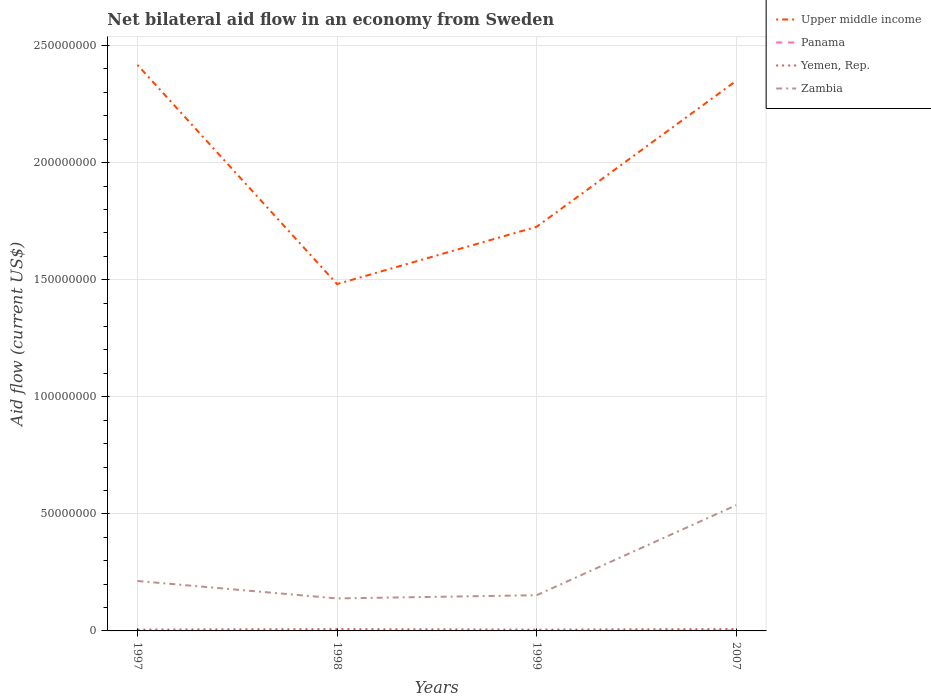Is the number of lines equal to the number of legend labels?
Ensure brevity in your answer.  Yes. Across all years, what is the maximum net bilateral aid flow in Upper middle income?
Offer a very short reply. 1.48e+08. In which year was the net bilateral aid flow in Yemen, Rep. maximum?
Your response must be concise. 1999. What is the difference between the highest and the lowest net bilateral aid flow in Yemen, Rep.?
Give a very brief answer. 2. Is the net bilateral aid flow in Zambia strictly greater than the net bilateral aid flow in Upper middle income over the years?
Your answer should be very brief. Yes. How many lines are there?
Offer a very short reply. 4. What is the difference between two consecutive major ticks on the Y-axis?
Keep it short and to the point. 5.00e+07. Are the values on the major ticks of Y-axis written in scientific E-notation?
Ensure brevity in your answer.  No. Does the graph contain any zero values?
Offer a very short reply. No. Does the graph contain grids?
Ensure brevity in your answer.  Yes. Where does the legend appear in the graph?
Your answer should be compact. Top right. What is the title of the graph?
Offer a very short reply. Net bilateral aid flow in an economy from Sweden. Does "Georgia" appear as one of the legend labels in the graph?
Offer a very short reply. No. What is the label or title of the Y-axis?
Provide a short and direct response. Aid flow (current US$). What is the Aid flow (current US$) in Upper middle income in 1997?
Provide a succinct answer. 2.42e+08. What is the Aid flow (current US$) of Yemen, Rep. in 1997?
Offer a terse response. 5.60e+05. What is the Aid flow (current US$) of Zambia in 1997?
Your answer should be very brief. 2.13e+07. What is the Aid flow (current US$) in Upper middle income in 1998?
Offer a terse response. 1.48e+08. What is the Aid flow (current US$) of Panama in 1998?
Your answer should be very brief. 2.00e+04. What is the Aid flow (current US$) in Yemen, Rep. in 1998?
Give a very brief answer. 7.70e+05. What is the Aid flow (current US$) in Zambia in 1998?
Ensure brevity in your answer.  1.39e+07. What is the Aid flow (current US$) of Upper middle income in 1999?
Provide a short and direct response. 1.73e+08. What is the Aid flow (current US$) in Panama in 1999?
Ensure brevity in your answer.  10000. What is the Aid flow (current US$) in Zambia in 1999?
Offer a terse response. 1.52e+07. What is the Aid flow (current US$) of Upper middle income in 2007?
Your answer should be very brief. 2.35e+08. What is the Aid flow (current US$) of Panama in 2007?
Provide a succinct answer. 1.40e+05. What is the Aid flow (current US$) in Yemen, Rep. in 2007?
Your answer should be compact. 8.00e+05. What is the Aid flow (current US$) in Zambia in 2007?
Offer a terse response. 5.37e+07. Across all years, what is the maximum Aid flow (current US$) in Upper middle income?
Your answer should be compact. 2.42e+08. Across all years, what is the maximum Aid flow (current US$) of Panama?
Ensure brevity in your answer.  1.40e+05. Across all years, what is the maximum Aid flow (current US$) of Yemen, Rep.?
Your answer should be compact. 8.00e+05. Across all years, what is the maximum Aid flow (current US$) of Zambia?
Your response must be concise. 5.37e+07. Across all years, what is the minimum Aid flow (current US$) in Upper middle income?
Keep it short and to the point. 1.48e+08. Across all years, what is the minimum Aid flow (current US$) in Yemen, Rep.?
Ensure brevity in your answer.  5.50e+05. Across all years, what is the minimum Aid flow (current US$) of Zambia?
Ensure brevity in your answer.  1.39e+07. What is the total Aid flow (current US$) in Upper middle income in the graph?
Ensure brevity in your answer.  7.97e+08. What is the total Aid flow (current US$) of Panama in the graph?
Give a very brief answer. 1.90e+05. What is the total Aid flow (current US$) of Yemen, Rep. in the graph?
Ensure brevity in your answer.  2.68e+06. What is the total Aid flow (current US$) in Zambia in the graph?
Offer a very short reply. 1.04e+08. What is the difference between the Aid flow (current US$) of Upper middle income in 1997 and that in 1998?
Give a very brief answer. 9.36e+07. What is the difference between the Aid flow (current US$) of Zambia in 1997 and that in 1998?
Provide a short and direct response. 7.44e+06. What is the difference between the Aid flow (current US$) of Upper middle income in 1997 and that in 1999?
Make the answer very short. 6.91e+07. What is the difference between the Aid flow (current US$) of Zambia in 1997 and that in 1999?
Keep it short and to the point. 6.07e+06. What is the difference between the Aid flow (current US$) in Upper middle income in 1997 and that in 2007?
Ensure brevity in your answer.  6.81e+06. What is the difference between the Aid flow (current US$) of Yemen, Rep. in 1997 and that in 2007?
Provide a succinct answer. -2.40e+05. What is the difference between the Aid flow (current US$) in Zambia in 1997 and that in 2007?
Offer a terse response. -3.24e+07. What is the difference between the Aid flow (current US$) in Upper middle income in 1998 and that in 1999?
Offer a terse response. -2.45e+07. What is the difference between the Aid flow (current US$) of Zambia in 1998 and that in 1999?
Give a very brief answer. -1.37e+06. What is the difference between the Aid flow (current US$) in Upper middle income in 1998 and that in 2007?
Your answer should be compact. -8.68e+07. What is the difference between the Aid flow (current US$) in Panama in 1998 and that in 2007?
Provide a succinct answer. -1.20e+05. What is the difference between the Aid flow (current US$) in Yemen, Rep. in 1998 and that in 2007?
Your answer should be very brief. -3.00e+04. What is the difference between the Aid flow (current US$) in Zambia in 1998 and that in 2007?
Offer a terse response. -3.98e+07. What is the difference between the Aid flow (current US$) of Upper middle income in 1999 and that in 2007?
Ensure brevity in your answer.  -6.23e+07. What is the difference between the Aid flow (current US$) of Yemen, Rep. in 1999 and that in 2007?
Ensure brevity in your answer.  -2.50e+05. What is the difference between the Aid flow (current US$) in Zambia in 1999 and that in 2007?
Your answer should be compact. -3.84e+07. What is the difference between the Aid flow (current US$) in Upper middle income in 1997 and the Aid flow (current US$) in Panama in 1998?
Ensure brevity in your answer.  2.42e+08. What is the difference between the Aid flow (current US$) of Upper middle income in 1997 and the Aid flow (current US$) of Yemen, Rep. in 1998?
Your answer should be compact. 2.41e+08. What is the difference between the Aid flow (current US$) of Upper middle income in 1997 and the Aid flow (current US$) of Zambia in 1998?
Keep it short and to the point. 2.28e+08. What is the difference between the Aid flow (current US$) of Panama in 1997 and the Aid flow (current US$) of Yemen, Rep. in 1998?
Provide a succinct answer. -7.50e+05. What is the difference between the Aid flow (current US$) in Panama in 1997 and the Aid flow (current US$) in Zambia in 1998?
Offer a terse response. -1.39e+07. What is the difference between the Aid flow (current US$) of Yemen, Rep. in 1997 and the Aid flow (current US$) of Zambia in 1998?
Your response must be concise. -1.33e+07. What is the difference between the Aid flow (current US$) in Upper middle income in 1997 and the Aid flow (current US$) in Panama in 1999?
Give a very brief answer. 2.42e+08. What is the difference between the Aid flow (current US$) in Upper middle income in 1997 and the Aid flow (current US$) in Yemen, Rep. in 1999?
Your answer should be very brief. 2.41e+08. What is the difference between the Aid flow (current US$) of Upper middle income in 1997 and the Aid flow (current US$) of Zambia in 1999?
Your answer should be very brief. 2.26e+08. What is the difference between the Aid flow (current US$) in Panama in 1997 and the Aid flow (current US$) in Yemen, Rep. in 1999?
Keep it short and to the point. -5.30e+05. What is the difference between the Aid flow (current US$) in Panama in 1997 and the Aid flow (current US$) in Zambia in 1999?
Provide a succinct answer. -1.52e+07. What is the difference between the Aid flow (current US$) in Yemen, Rep. in 1997 and the Aid flow (current US$) in Zambia in 1999?
Offer a terse response. -1.47e+07. What is the difference between the Aid flow (current US$) of Upper middle income in 1997 and the Aid flow (current US$) of Panama in 2007?
Provide a succinct answer. 2.42e+08. What is the difference between the Aid flow (current US$) of Upper middle income in 1997 and the Aid flow (current US$) of Yemen, Rep. in 2007?
Ensure brevity in your answer.  2.41e+08. What is the difference between the Aid flow (current US$) in Upper middle income in 1997 and the Aid flow (current US$) in Zambia in 2007?
Ensure brevity in your answer.  1.88e+08. What is the difference between the Aid flow (current US$) in Panama in 1997 and the Aid flow (current US$) in Yemen, Rep. in 2007?
Your answer should be very brief. -7.80e+05. What is the difference between the Aid flow (current US$) of Panama in 1997 and the Aid flow (current US$) of Zambia in 2007?
Ensure brevity in your answer.  -5.37e+07. What is the difference between the Aid flow (current US$) of Yemen, Rep. in 1997 and the Aid flow (current US$) of Zambia in 2007?
Give a very brief answer. -5.31e+07. What is the difference between the Aid flow (current US$) in Upper middle income in 1998 and the Aid flow (current US$) in Panama in 1999?
Give a very brief answer. 1.48e+08. What is the difference between the Aid flow (current US$) of Upper middle income in 1998 and the Aid flow (current US$) of Yemen, Rep. in 1999?
Ensure brevity in your answer.  1.48e+08. What is the difference between the Aid flow (current US$) in Upper middle income in 1998 and the Aid flow (current US$) in Zambia in 1999?
Make the answer very short. 1.33e+08. What is the difference between the Aid flow (current US$) in Panama in 1998 and the Aid flow (current US$) in Yemen, Rep. in 1999?
Provide a short and direct response. -5.30e+05. What is the difference between the Aid flow (current US$) in Panama in 1998 and the Aid flow (current US$) in Zambia in 1999?
Keep it short and to the point. -1.52e+07. What is the difference between the Aid flow (current US$) of Yemen, Rep. in 1998 and the Aid flow (current US$) of Zambia in 1999?
Your answer should be very brief. -1.45e+07. What is the difference between the Aid flow (current US$) in Upper middle income in 1998 and the Aid flow (current US$) in Panama in 2007?
Your answer should be compact. 1.48e+08. What is the difference between the Aid flow (current US$) of Upper middle income in 1998 and the Aid flow (current US$) of Yemen, Rep. in 2007?
Ensure brevity in your answer.  1.47e+08. What is the difference between the Aid flow (current US$) of Upper middle income in 1998 and the Aid flow (current US$) of Zambia in 2007?
Provide a succinct answer. 9.44e+07. What is the difference between the Aid flow (current US$) of Panama in 1998 and the Aid flow (current US$) of Yemen, Rep. in 2007?
Provide a succinct answer. -7.80e+05. What is the difference between the Aid flow (current US$) of Panama in 1998 and the Aid flow (current US$) of Zambia in 2007?
Provide a short and direct response. -5.37e+07. What is the difference between the Aid flow (current US$) in Yemen, Rep. in 1998 and the Aid flow (current US$) in Zambia in 2007?
Your answer should be compact. -5.29e+07. What is the difference between the Aid flow (current US$) in Upper middle income in 1999 and the Aid flow (current US$) in Panama in 2007?
Ensure brevity in your answer.  1.72e+08. What is the difference between the Aid flow (current US$) in Upper middle income in 1999 and the Aid flow (current US$) in Yemen, Rep. in 2007?
Offer a very short reply. 1.72e+08. What is the difference between the Aid flow (current US$) of Upper middle income in 1999 and the Aid flow (current US$) of Zambia in 2007?
Your response must be concise. 1.19e+08. What is the difference between the Aid flow (current US$) in Panama in 1999 and the Aid flow (current US$) in Yemen, Rep. in 2007?
Your answer should be very brief. -7.90e+05. What is the difference between the Aid flow (current US$) of Panama in 1999 and the Aid flow (current US$) of Zambia in 2007?
Make the answer very short. -5.37e+07. What is the difference between the Aid flow (current US$) of Yemen, Rep. in 1999 and the Aid flow (current US$) of Zambia in 2007?
Keep it short and to the point. -5.31e+07. What is the average Aid flow (current US$) of Upper middle income per year?
Provide a succinct answer. 1.99e+08. What is the average Aid flow (current US$) in Panama per year?
Make the answer very short. 4.75e+04. What is the average Aid flow (current US$) in Yemen, Rep. per year?
Keep it short and to the point. 6.70e+05. What is the average Aid flow (current US$) of Zambia per year?
Keep it short and to the point. 2.60e+07. In the year 1997, what is the difference between the Aid flow (current US$) of Upper middle income and Aid flow (current US$) of Panama?
Your answer should be very brief. 2.42e+08. In the year 1997, what is the difference between the Aid flow (current US$) of Upper middle income and Aid flow (current US$) of Yemen, Rep.?
Ensure brevity in your answer.  2.41e+08. In the year 1997, what is the difference between the Aid flow (current US$) of Upper middle income and Aid flow (current US$) of Zambia?
Provide a short and direct response. 2.20e+08. In the year 1997, what is the difference between the Aid flow (current US$) in Panama and Aid flow (current US$) in Yemen, Rep.?
Give a very brief answer. -5.40e+05. In the year 1997, what is the difference between the Aid flow (current US$) of Panama and Aid flow (current US$) of Zambia?
Make the answer very short. -2.13e+07. In the year 1997, what is the difference between the Aid flow (current US$) of Yemen, Rep. and Aid flow (current US$) of Zambia?
Give a very brief answer. -2.08e+07. In the year 1998, what is the difference between the Aid flow (current US$) in Upper middle income and Aid flow (current US$) in Panama?
Keep it short and to the point. 1.48e+08. In the year 1998, what is the difference between the Aid flow (current US$) of Upper middle income and Aid flow (current US$) of Yemen, Rep.?
Your answer should be compact. 1.47e+08. In the year 1998, what is the difference between the Aid flow (current US$) in Upper middle income and Aid flow (current US$) in Zambia?
Offer a terse response. 1.34e+08. In the year 1998, what is the difference between the Aid flow (current US$) in Panama and Aid flow (current US$) in Yemen, Rep.?
Provide a succinct answer. -7.50e+05. In the year 1998, what is the difference between the Aid flow (current US$) of Panama and Aid flow (current US$) of Zambia?
Give a very brief answer. -1.39e+07. In the year 1998, what is the difference between the Aid flow (current US$) in Yemen, Rep. and Aid flow (current US$) in Zambia?
Provide a succinct answer. -1.31e+07. In the year 1999, what is the difference between the Aid flow (current US$) in Upper middle income and Aid flow (current US$) in Panama?
Provide a short and direct response. 1.73e+08. In the year 1999, what is the difference between the Aid flow (current US$) of Upper middle income and Aid flow (current US$) of Yemen, Rep.?
Provide a succinct answer. 1.72e+08. In the year 1999, what is the difference between the Aid flow (current US$) of Upper middle income and Aid flow (current US$) of Zambia?
Keep it short and to the point. 1.57e+08. In the year 1999, what is the difference between the Aid flow (current US$) in Panama and Aid flow (current US$) in Yemen, Rep.?
Offer a very short reply. -5.40e+05. In the year 1999, what is the difference between the Aid flow (current US$) of Panama and Aid flow (current US$) of Zambia?
Ensure brevity in your answer.  -1.52e+07. In the year 1999, what is the difference between the Aid flow (current US$) of Yemen, Rep. and Aid flow (current US$) of Zambia?
Give a very brief answer. -1.47e+07. In the year 2007, what is the difference between the Aid flow (current US$) of Upper middle income and Aid flow (current US$) of Panama?
Make the answer very short. 2.35e+08. In the year 2007, what is the difference between the Aid flow (current US$) of Upper middle income and Aid flow (current US$) of Yemen, Rep.?
Offer a terse response. 2.34e+08. In the year 2007, what is the difference between the Aid flow (current US$) of Upper middle income and Aid flow (current US$) of Zambia?
Your response must be concise. 1.81e+08. In the year 2007, what is the difference between the Aid flow (current US$) of Panama and Aid flow (current US$) of Yemen, Rep.?
Provide a short and direct response. -6.60e+05. In the year 2007, what is the difference between the Aid flow (current US$) in Panama and Aid flow (current US$) in Zambia?
Keep it short and to the point. -5.36e+07. In the year 2007, what is the difference between the Aid flow (current US$) of Yemen, Rep. and Aid flow (current US$) of Zambia?
Provide a short and direct response. -5.29e+07. What is the ratio of the Aid flow (current US$) of Upper middle income in 1997 to that in 1998?
Your answer should be very brief. 1.63. What is the ratio of the Aid flow (current US$) in Yemen, Rep. in 1997 to that in 1998?
Offer a very short reply. 0.73. What is the ratio of the Aid flow (current US$) in Zambia in 1997 to that in 1998?
Ensure brevity in your answer.  1.54. What is the ratio of the Aid flow (current US$) of Upper middle income in 1997 to that in 1999?
Offer a terse response. 1.4. What is the ratio of the Aid flow (current US$) in Yemen, Rep. in 1997 to that in 1999?
Ensure brevity in your answer.  1.02. What is the ratio of the Aid flow (current US$) of Zambia in 1997 to that in 1999?
Provide a short and direct response. 1.4. What is the ratio of the Aid flow (current US$) in Panama in 1997 to that in 2007?
Your answer should be compact. 0.14. What is the ratio of the Aid flow (current US$) of Zambia in 1997 to that in 2007?
Keep it short and to the point. 0.4. What is the ratio of the Aid flow (current US$) of Upper middle income in 1998 to that in 1999?
Ensure brevity in your answer.  0.86. What is the ratio of the Aid flow (current US$) of Panama in 1998 to that in 1999?
Offer a very short reply. 2. What is the ratio of the Aid flow (current US$) in Yemen, Rep. in 1998 to that in 1999?
Your answer should be compact. 1.4. What is the ratio of the Aid flow (current US$) in Zambia in 1998 to that in 1999?
Your answer should be compact. 0.91. What is the ratio of the Aid flow (current US$) of Upper middle income in 1998 to that in 2007?
Make the answer very short. 0.63. What is the ratio of the Aid flow (current US$) of Panama in 1998 to that in 2007?
Provide a succinct answer. 0.14. What is the ratio of the Aid flow (current US$) of Yemen, Rep. in 1998 to that in 2007?
Offer a very short reply. 0.96. What is the ratio of the Aid flow (current US$) in Zambia in 1998 to that in 2007?
Offer a terse response. 0.26. What is the ratio of the Aid flow (current US$) of Upper middle income in 1999 to that in 2007?
Your answer should be compact. 0.73. What is the ratio of the Aid flow (current US$) of Panama in 1999 to that in 2007?
Ensure brevity in your answer.  0.07. What is the ratio of the Aid flow (current US$) of Yemen, Rep. in 1999 to that in 2007?
Provide a succinct answer. 0.69. What is the ratio of the Aid flow (current US$) in Zambia in 1999 to that in 2007?
Offer a terse response. 0.28. What is the difference between the highest and the second highest Aid flow (current US$) of Upper middle income?
Offer a very short reply. 6.81e+06. What is the difference between the highest and the second highest Aid flow (current US$) in Panama?
Give a very brief answer. 1.20e+05. What is the difference between the highest and the second highest Aid flow (current US$) of Zambia?
Offer a very short reply. 3.24e+07. What is the difference between the highest and the lowest Aid flow (current US$) in Upper middle income?
Offer a very short reply. 9.36e+07. What is the difference between the highest and the lowest Aid flow (current US$) in Panama?
Give a very brief answer. 1.30e+05. What is the difference between the highest and the lowest Aid flow (current US$) in Yemen, Rep.?
Provide a short and direct response. 2.50e+05. What is the difference between the highest and the lowest Aid flow (current US$) of Zambia?
Provide a short and direct response. 3.98e+07. 